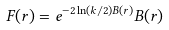<formula> <loc_0><loc_0><loc_500><loc_500>F ( r ) = e ^ { - 2 \ln ( k / 2 ) B ( r ) } B ( r )</formula> 